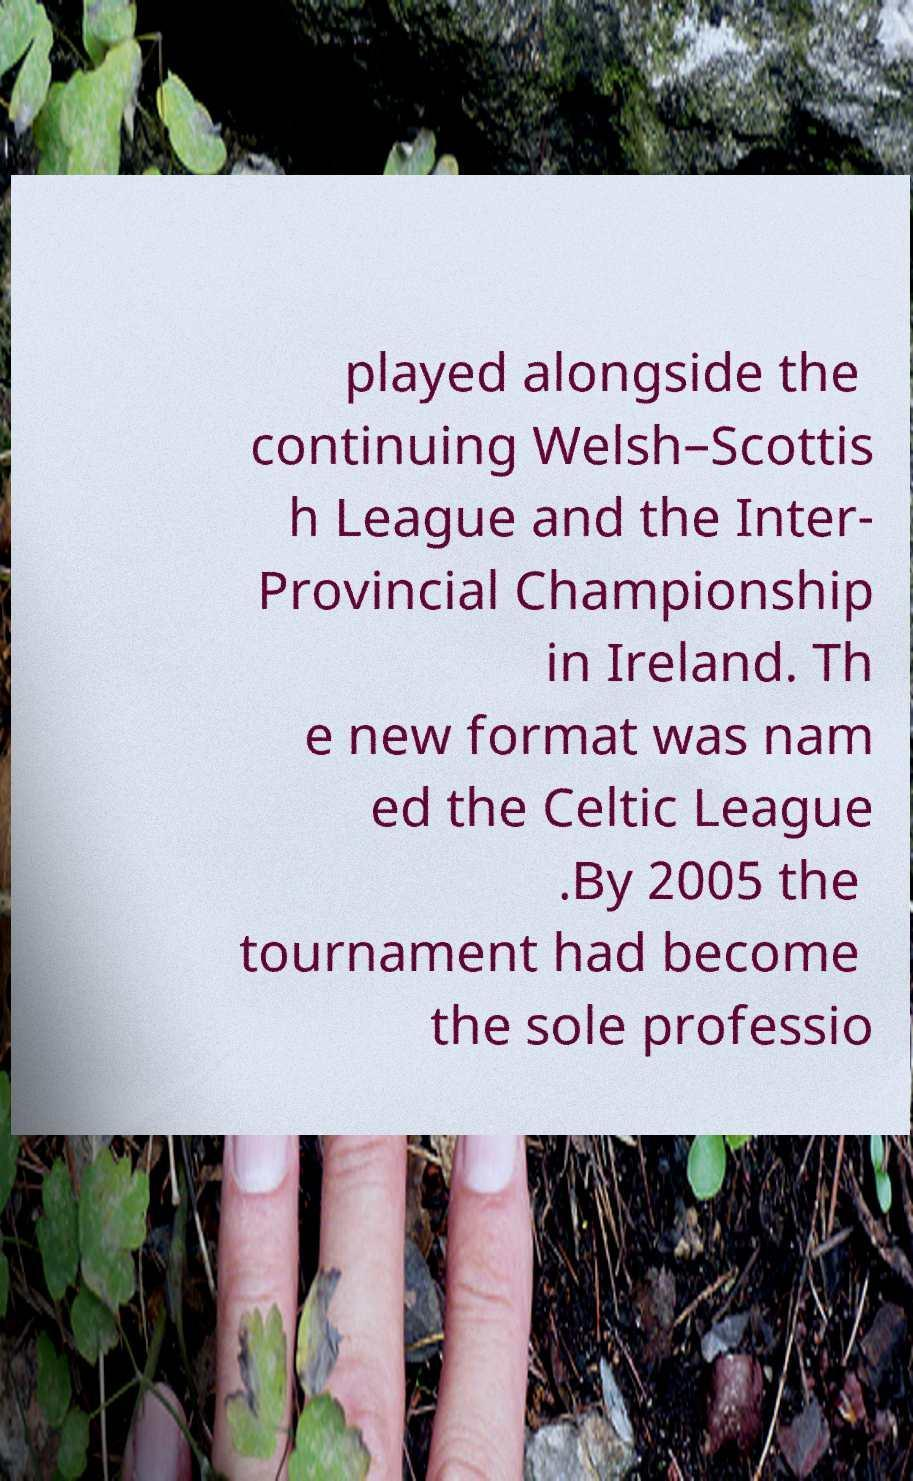There's text embedded in this image that I need extracted. Can you transcribe it verbatim? played alongside the continuing Welsh–Scottis h League and the Inter- Provincial Championship in Ireland. Th e new format was nam ed the Celtic League .By 2005 the tournament had become the sole professio 